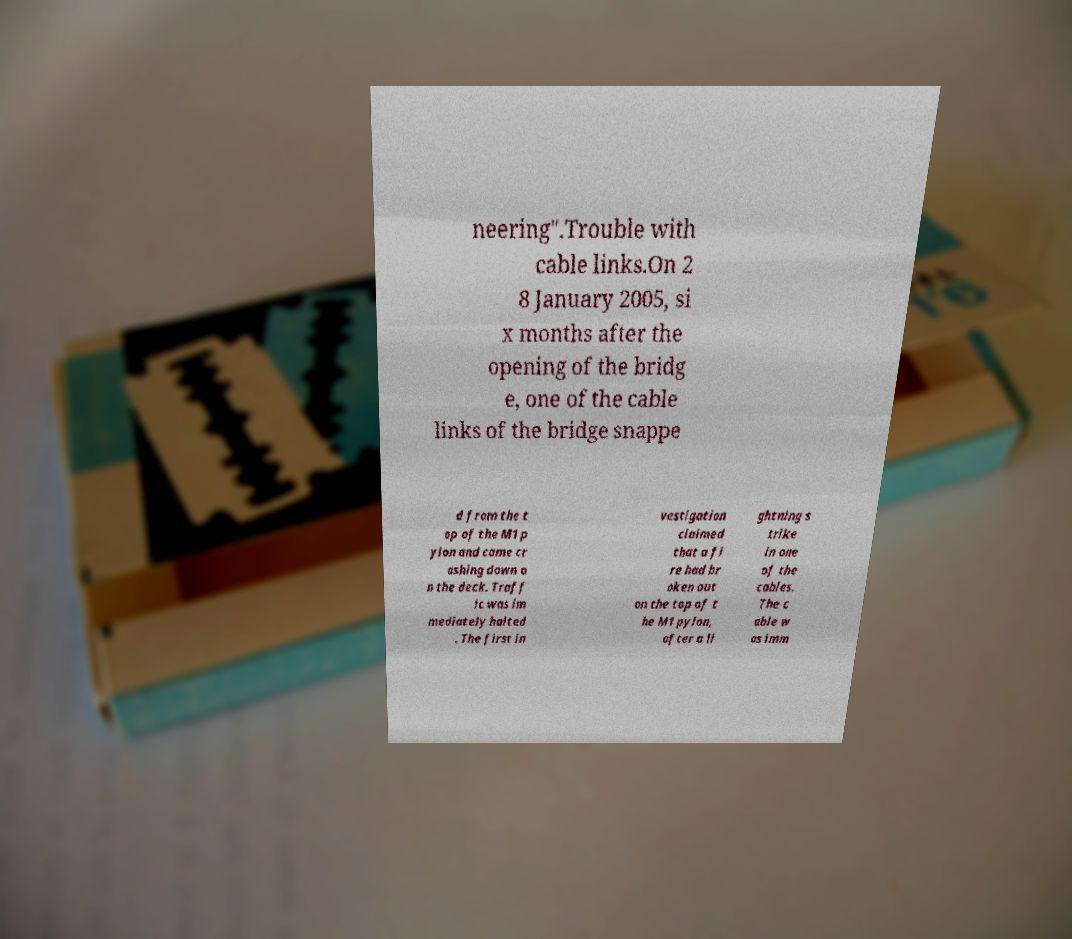What messages or text are displayed in this image? I need them in a readable, typed format. neering".Trouble with cable links.On 2 8 January 2005, si x months after the opening of the bridg e, one of the cable links of the bridge snappe d from the t op of the M1 p ylon and came cr ashing down o n the deck. Traff ic was im mediately halted . The first in vestigation claimed that a fi re had br oken out on the top of t he M1 pylon, after a li ghtning s trike in one of the cables. The c able w as imm 